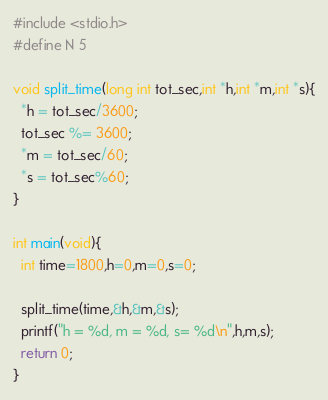Convert code to text. <code><loc_0><loc_0><loc_500><loc_500><_C_>#include <stdio.h>
#define N 5

void split_time(long int tot_sec,int *h,int *m,int *s){
  *h = tot_sec/3600;
  tot_sec %= 3600;
  *m = tot_sec/60;
  *s = tot_sec%60;
}

int main(void){
  int time=1800,h=0,m=0,s=0;

  split_time(time,&h,&m,&s);
  printf("h = %d, m = %d, s= %d\n",h,m,s);
  return 0;
}
</code> 